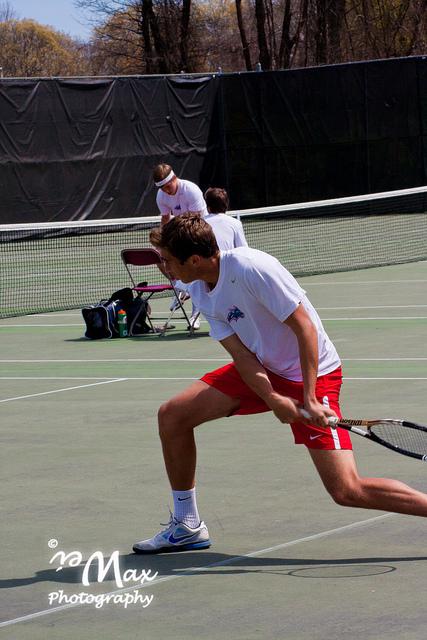What color are the man's shorts?
Write a very short answer. Red. What is the man holding?
Short answer required. Racket. What time of day is it?
Be succinct. Afternoon. 